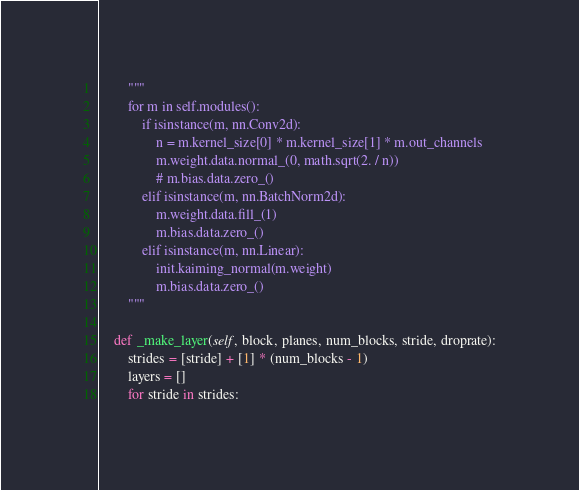Convert code to text. <code><loc_0><loc_0><loc_500><loc_500><_Python_>        """
        for m in self.modules():
            if isinstance(m, nn.Conv2d):
                n = m.kernel_size[0] * m.kernel_size[1] * m.out_channels
                m.weight.data.normal_(0, math.sqrt(2. / n))
                # m.bias.data.zero_()
            elif isinstance(m, nn.BatchNorm2d):
                m.weight.data.fill_(1)
                m.bias.data.zero_()
            elif isinstance(m, nn.Linear):
                init.kaiming_normal(m.weight)
                m.bias.data.zero_()
        """

    def _make_layer(self, block, planes, num_blocks, stride, droprate):
        strides = [stride] + [1] * (num_blocks - 1)
        layers = []
        for stride in strides:</code> 